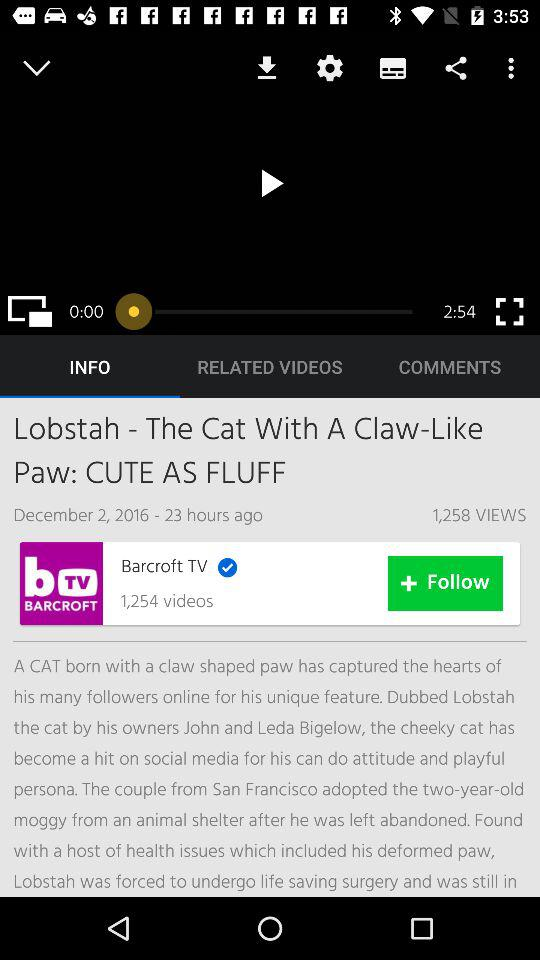How many hours ago was the video uploaded? The video was uploaded 23 hours ago. 